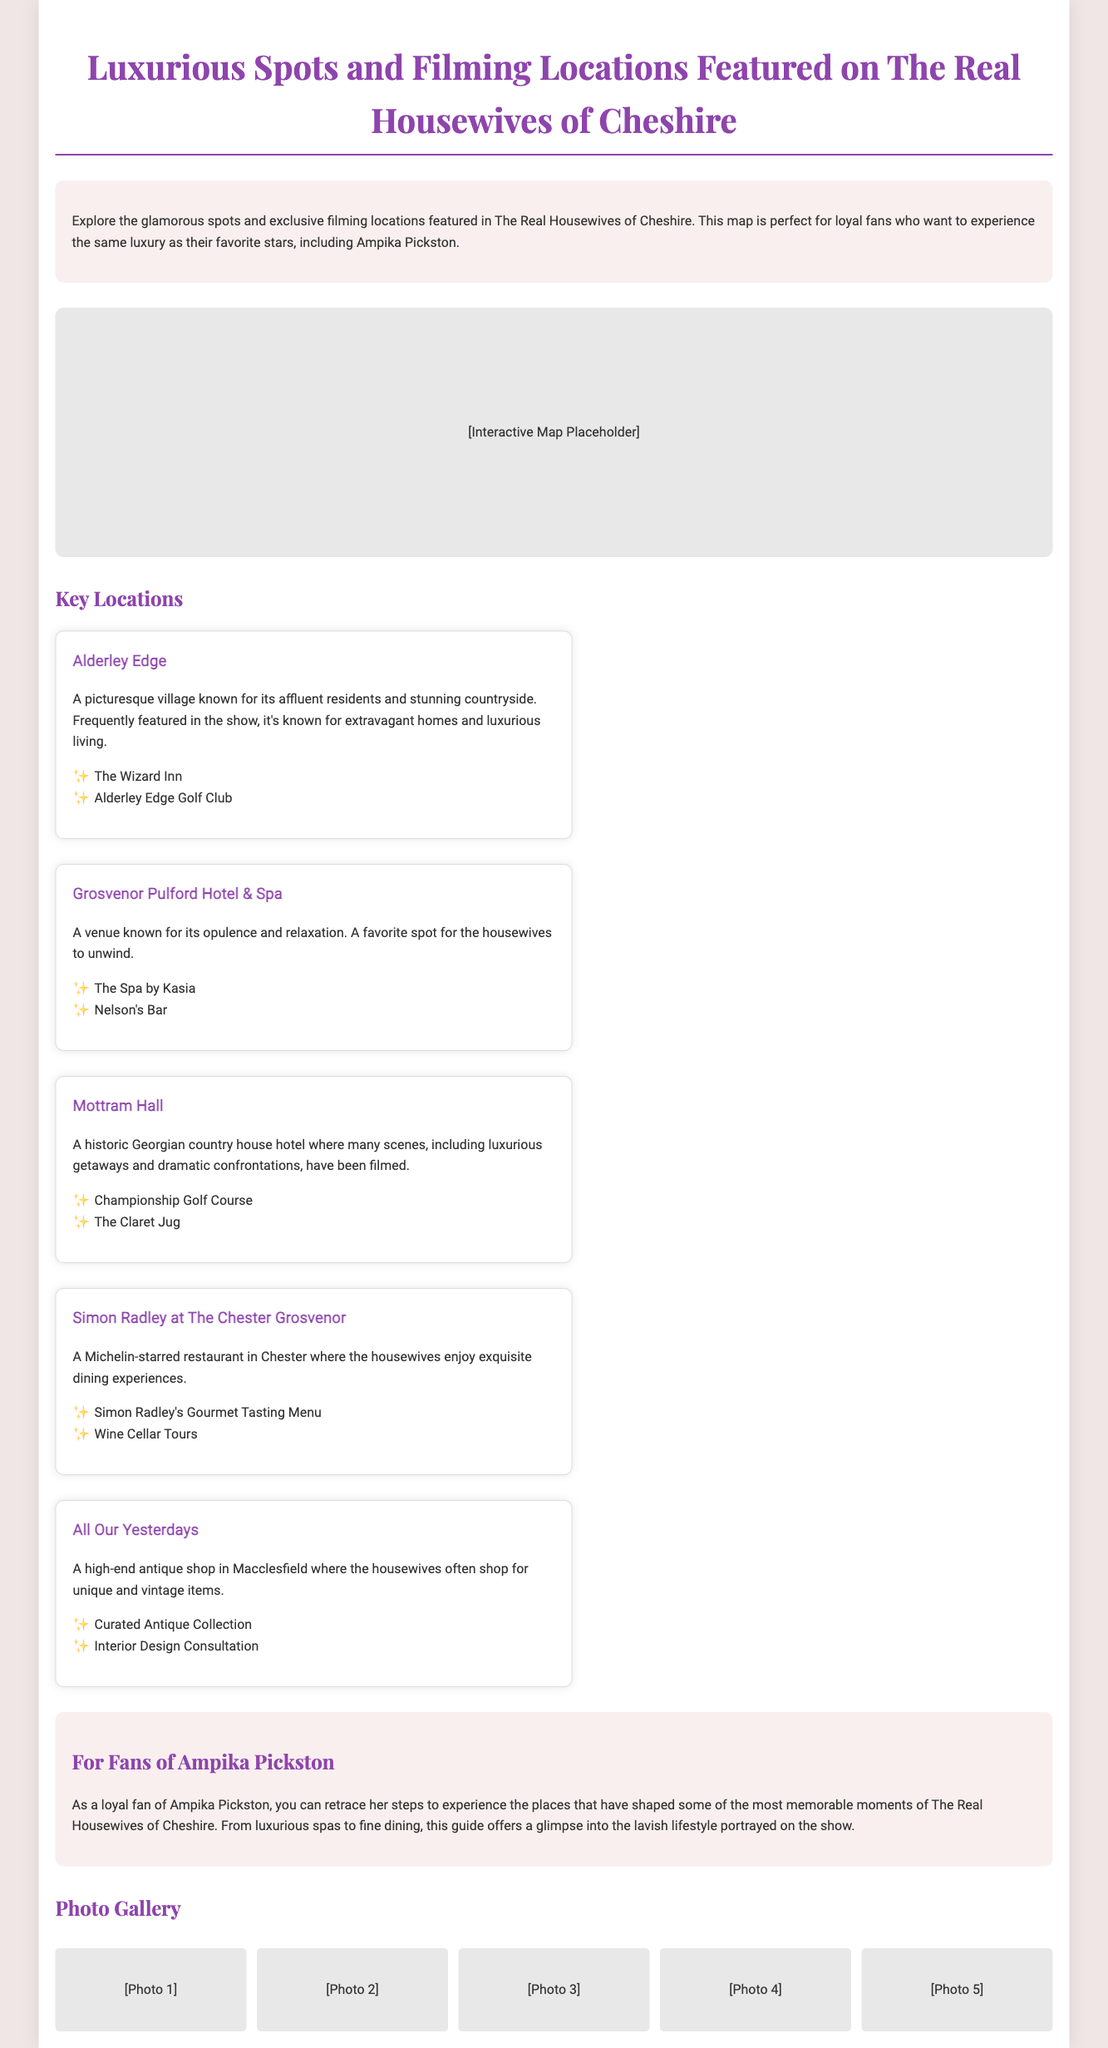What is the title of the document? The title appears as the main heading in the document, which is prominently displayed at the top.
Answer: Luxurious Spots and Filming Locations Featured on The Real Housewives of Cheshire How many key locations are listed? The document provides a section titled "Key Locations" that includes multiple entries detailing those locations.
Answer: Five What is one location featured in the document? The document lists several locations in the "Key Locations" section; one example can be retrieved directly from it.
Answer: Alderley Edge Which restaurant in Chester is mentioned? The document specifies a restaurant noted for its Michelin-starred status under the key locations.
Answer: Simon Radley at The Chester Grosvenor What type of venue is Grosvenor Pulford Hotel & Spa? This information is straightforwardly described in the description of the location, detailing its purpose and offerings.
Answer: Opulence and relaxation What is the Michelin-starred restaurant known for? The document highlights dining experiences offered at the restaurant, specifically focusing on its unique offerings.
Answer: Exquisite dining experiences What is the main theme of the document? The primary focus can be inferred from the introduction and the overarching titles in the document that establish its purpose.
Answer: Luxurious spots and filming locations What collection type is featured at All Our Yesterdays? The description gives insight into the kind of items available at this particular location.
Answer: Curated Antique Collection 